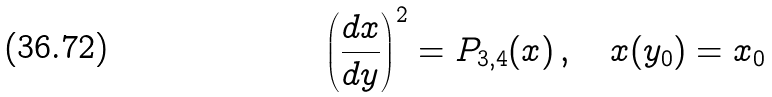Convert formula to latex. <formula><loc_0><loc_0><loc_500><loc_500>\left ( \frac { d x } { d y } \right ) ^ { 2 } & = P _ { 3 , 4 } ( x ) \, , \quad x ( y _ { 0 } ) = x _ { 0 }</formula> 